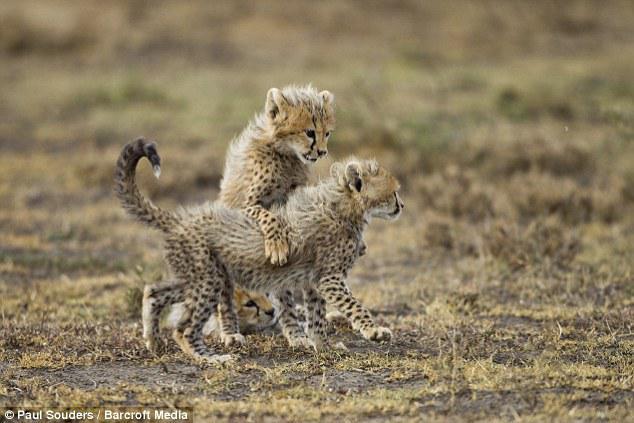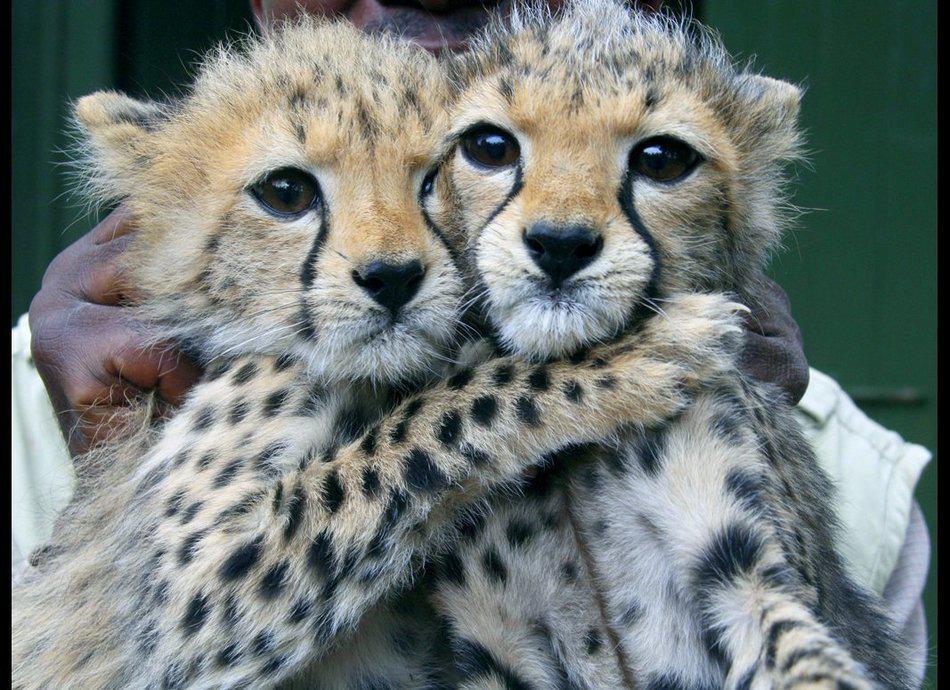The first image is the image on the left, the second image is the image on the right. Assess this claim about the two images: "A cheetah kitten is draping one front paw over part of another cheetah and has its head above the other cheetah.". Correct or not? Answer yes or no. Yes. The first image is the image on the left, the second image is the image on the right. Considering the images on both sides, is "A cub is shown hugging another leopard." valid? Answer yes or no. Yes. 